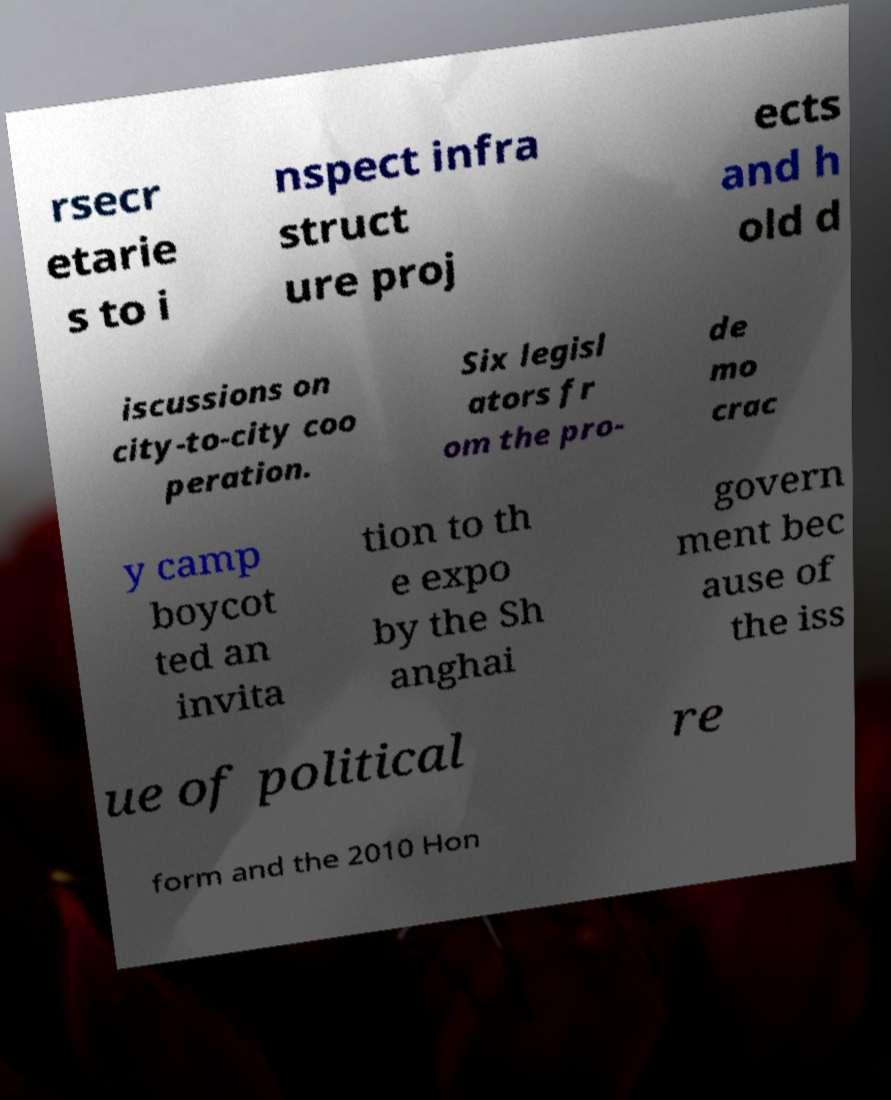For documentation purposes, I need the text within this image transcribed. Could you provide that? rsecr etarie s to i nspect infra struct ure proj ects and h old d iscussions on city-to-city coo peration. Six legisl ators fr om the pro- de mo crac y camp boycot ted an invita tion to th e expo by the Sh anghai govern ment bec ause of the iss ue of political re form and the 2010 Hon 